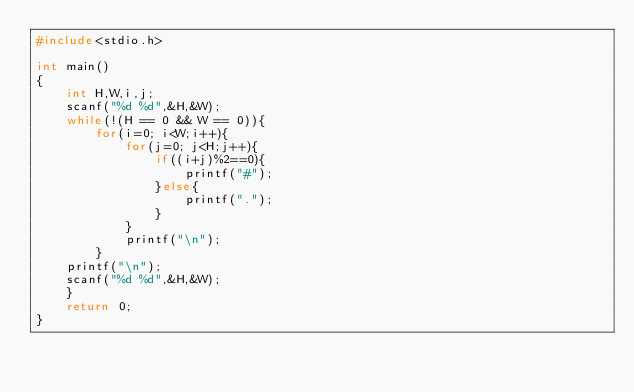<code> <loc_0><loc_0><loc_500><loc_500><_C_>#include<stdio.h>

int main()
{
    int H,W,i,j;
    scanf("%d %d",&H,&W);
    while(!(H == 0 && W == 0)){
    	for(i=0; i<W;i++){
    		for(j=0; j<H;j++){
    			if((i+j)%2==0){
    				printf("#");
    			}else{
    				printf(".");
    			}
    		}
    		printf("\n");
    	}
    printf("\n");
    scanf("%d %d",&H,&W);
    }
    return 0;
}</code> 